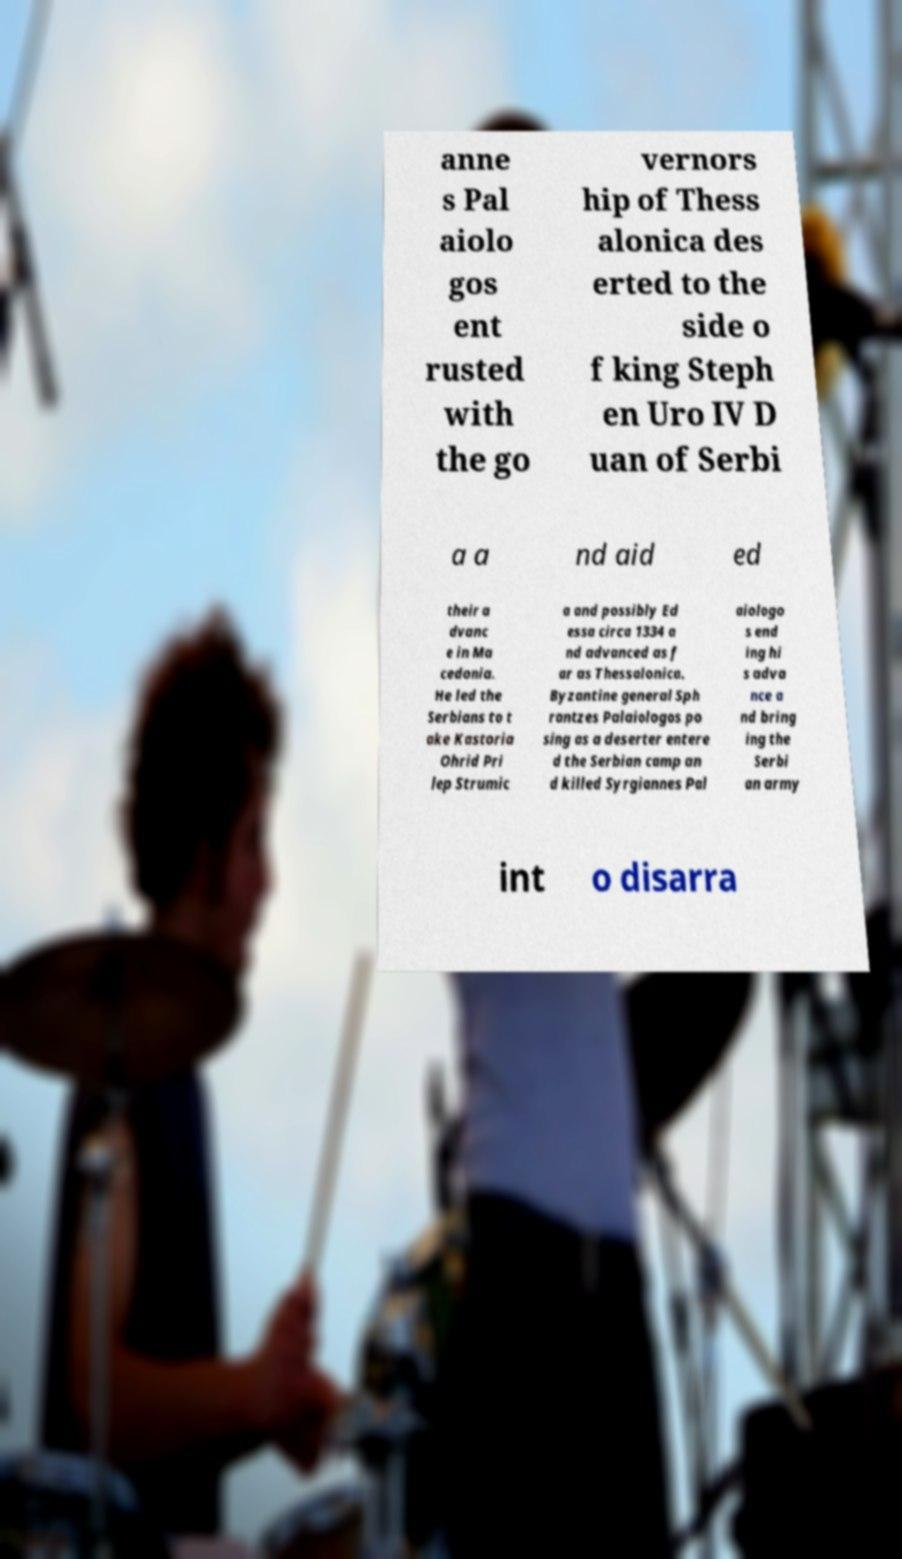For documentation purposes, I need the text within this image transcribed. Could you provide that? anne s Pal aiolo gos ent rusted with the go vernors hip of Thess alonica des erted to the side o f king Steph en Uro IV D uan of Serbi a a nd aid ed their a dvanc e in Ma cedonia. He led the Serbians to t ake Kastoria Ohrid Pri lep Strumic a and possibly Ed essa circa 1334 a nd advanced as f ar as Thessalonica. Byzantine general Sph rantzes Palaiologos po sing as a deserter entere d the Serbian camp an d killed Syrgiannes Pal aiologo s end ing hi s adva nce a nd bring ing the Serbi an army int o disarra 